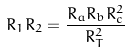Convert formula to latex. <formula><loc_0><loc_0><loc_500><loc_500>R _ { 1 } R _ { 2 } = \frac { R _ { a } R _ { b } R _ { c } ^ { 2 } } { R _ { T } ^ { 2 } }</formula> 